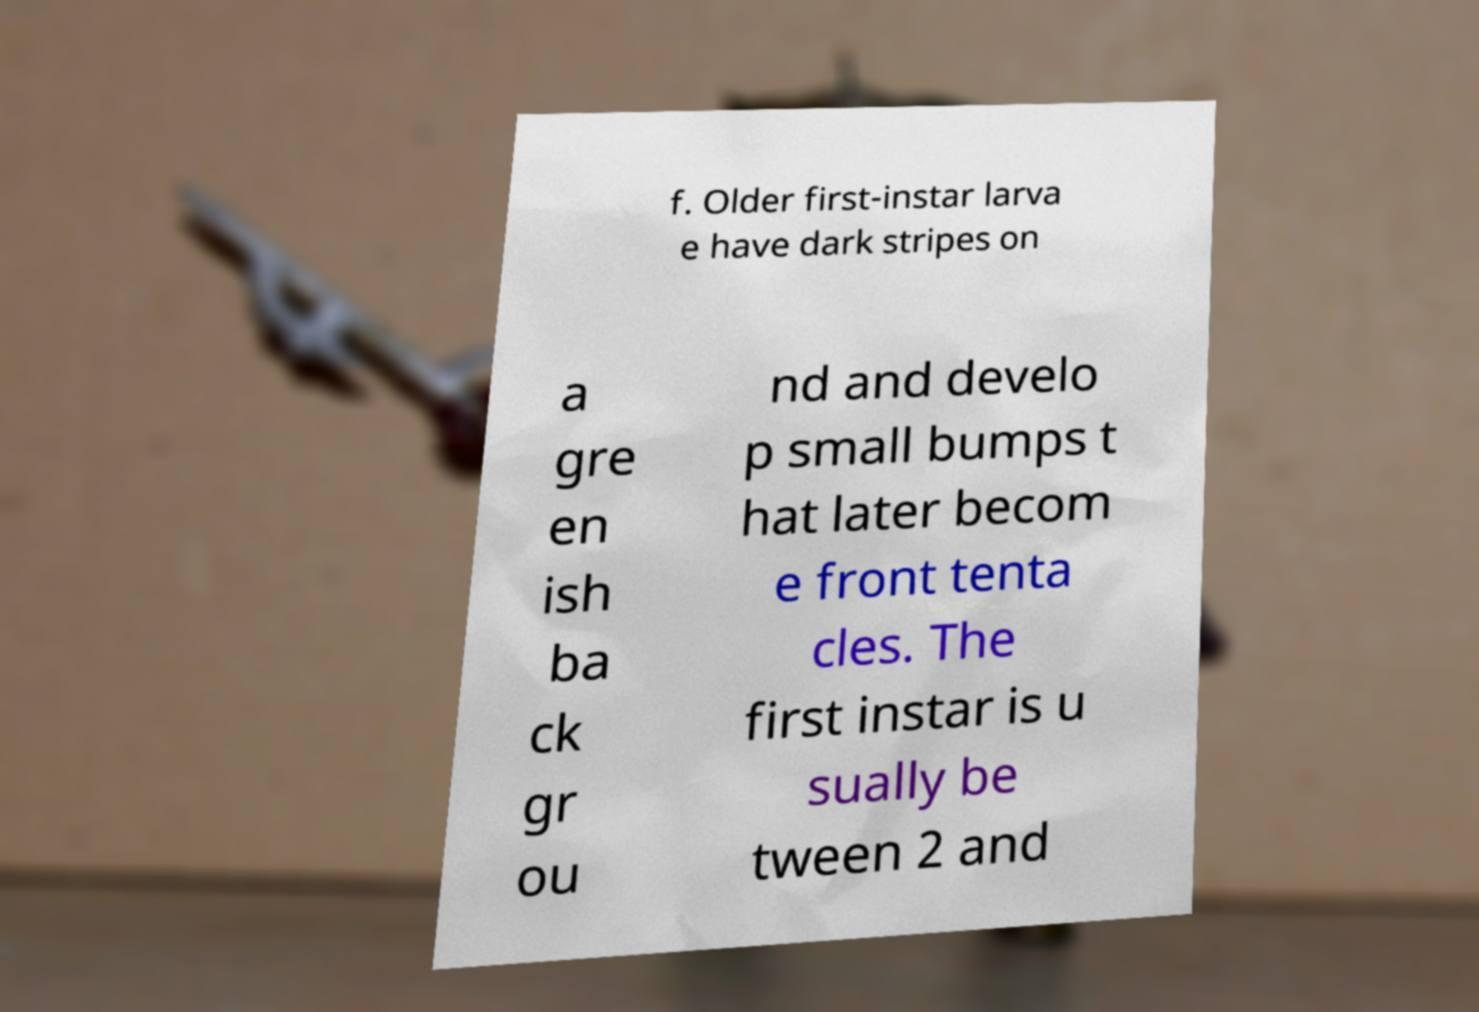Can you read and provide the text displayed in the image?This photo seems to have some interesting text. Can you extract and type it out for me? f. Older first-instar larva e have dark stripes on a gre en ish ba ck gr ou nd and develo p small bumps t hat later becom e front tenta cles. The first instar is u sually be tween 2 and 